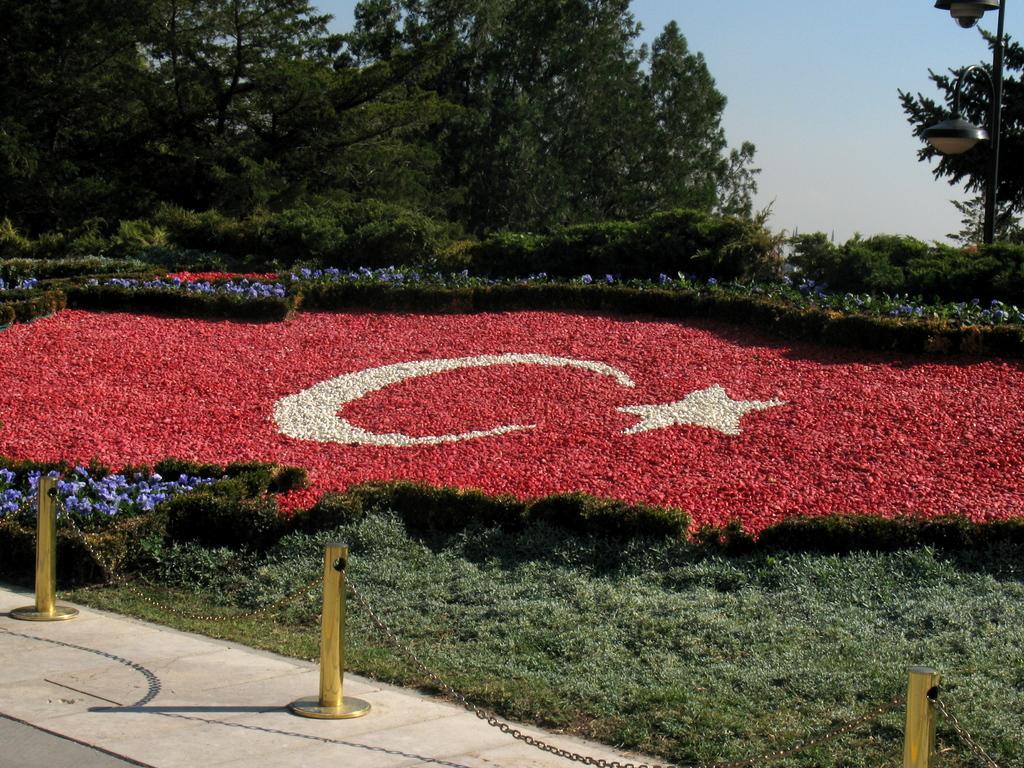In one or two sentences, can you explain what this image depicts? In this image we can see poles and chains barrier on a platform, plants with flowers, grass, lights on a pole on the right side, trees and clouds in the sky. 